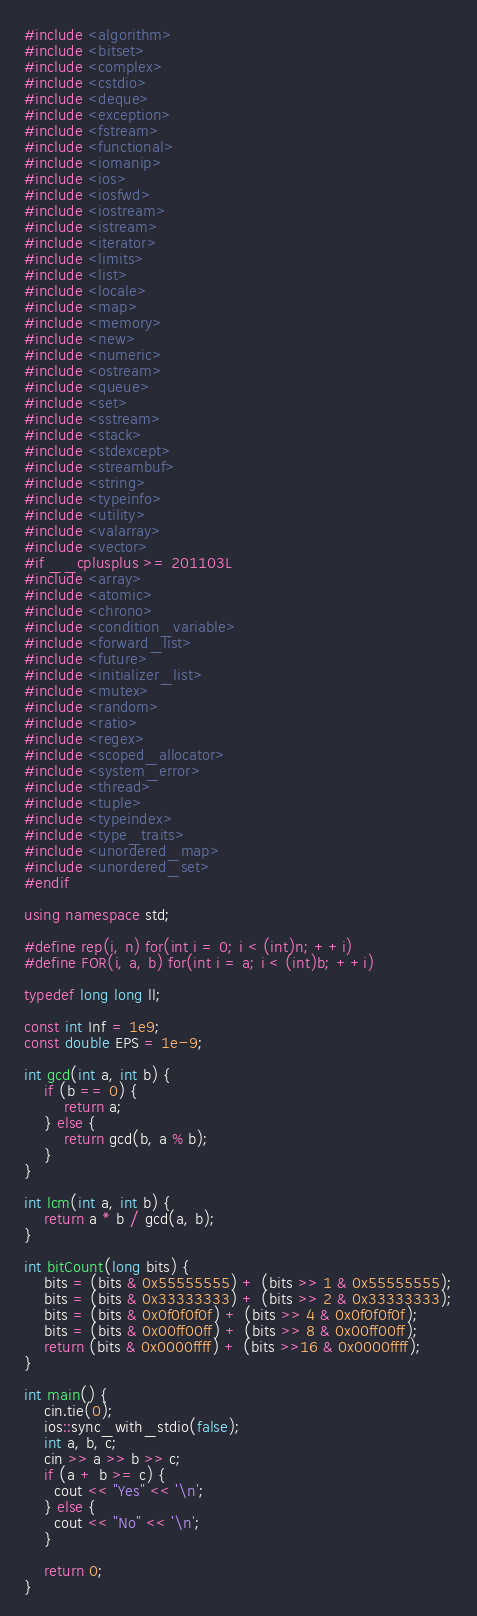Convert code to text. <code><loc_0><loc_0><loc_500><loc_500><_C++_>#include <algorithm>
#include <bitset>
#include <complex>
#include <cstdio>
#include <deque>
#include <exception>
#include <fstream>
#include <functional>
#include <iomanip>
#include <ios>
#include <iosfwd>
#include <iostream>
#include <istream>
#include <iterator>
#include <limits>
#include <list>
#include <locale>
#include <map>
#include <memory>
#include <new>
#include <numeric>
#include <ostream>
#include <queue>
#include <set>
#include <sstream>
#include <stack>
#include <stdexcept>
#include <streambuf>
#include <string>
#include <typeinfo>
#include <utility>
#include <valarray>
#include <vector>
#if __cplusplus >= 201103L
#include <array>
#include <atomic>
#include <chrono>
#include <condition_variable>
#include <forward_list>
#include <future>
#include <initializer_list>
#include <mutex>
#include <random>
#include <ratio>
#include <regex>
#include <scoped_allocator>
#include <system_error>
#include <thread>
#include <tuple>
#include <typeindex>
#include <type_traits>
#include <unordered_map>
#include <unordered_set>
#endif

using namespace std;

#define rep(i, n) for(int i = 0; i < (int)n; ++i)
#define FOR(i, a, b) for(int i = a; i < (int)b; ++i)

typedef long long ll;

const int Inf = 1e9;
const double EPS = 1e-9;

int gcd(int a, int b) {
    if (b == 0) {
        return a;
    } else {
        return gcd(b, a % b);
    }
}

int lcm(int a, int b) {
    return a * b / gcd(a, b);
}

int bitCount(long bits) {
    bits = (bits & 0x55555555) + (bits >> 1 & 0x55555555);
    bits = (bits & 0x33333333) + (bits >> 2 & 0x33333333);
    bits = (bits & 0x0f0f0f0f) + (bits >> 4 & 0x0f0f0f0f);
    bits = (bits & 0x00ff00ff) + (bits >> 8 & 0x00ff00ff);
    return (bits & 0x0000ffff) + (bits >>16 & 0x0000ffff);
}

int main() {
    cin.tie(0);
    ios::sync_with_stdio(false);
    int a, b, c;
    cin >> a >> b >> c;
    if (a + b >= c) {
      cout << "Yes" << '\n';
    } else {
      cout << "No" << '\n';
    }

    return 0;
}
</code> 